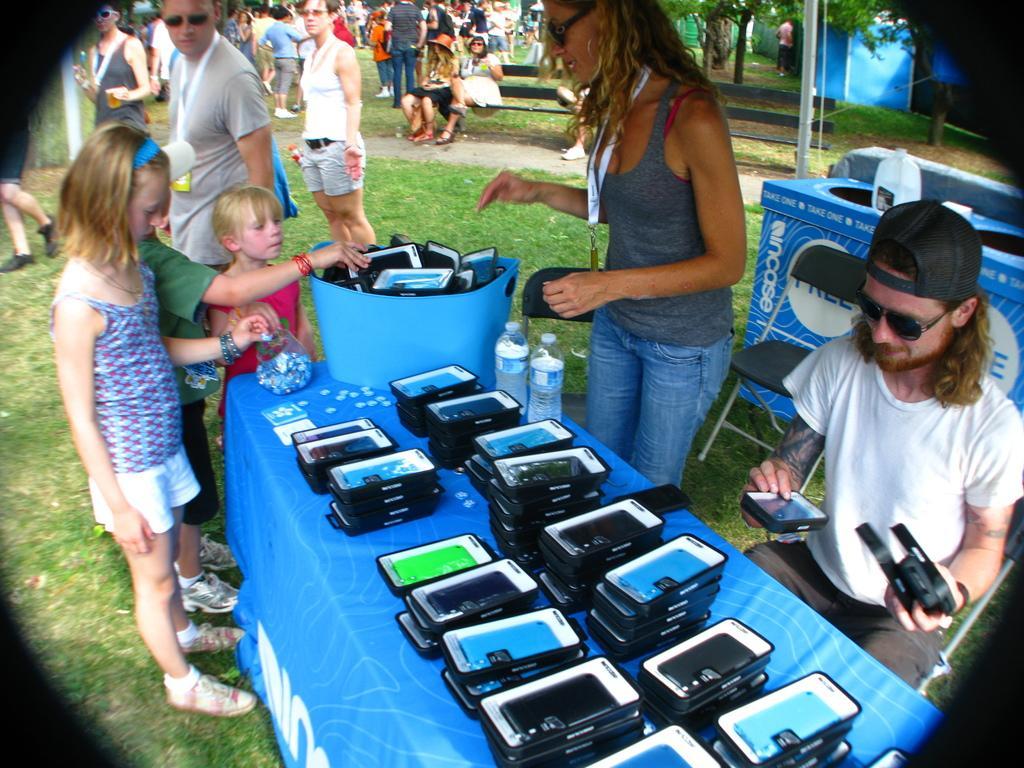Can you describe this image briefly? This woman is standing and wore id card. This man is sitting on a chair and wore goggles and cap. On this table there are mobiles, bottles and container. These three kids are standing in-front of this table. Far this group of people are standing and this two women are sitting on a bench. We can able to see trees and tent. Grass is in green color. This is a box in blue color, above this box there is a bottle. 